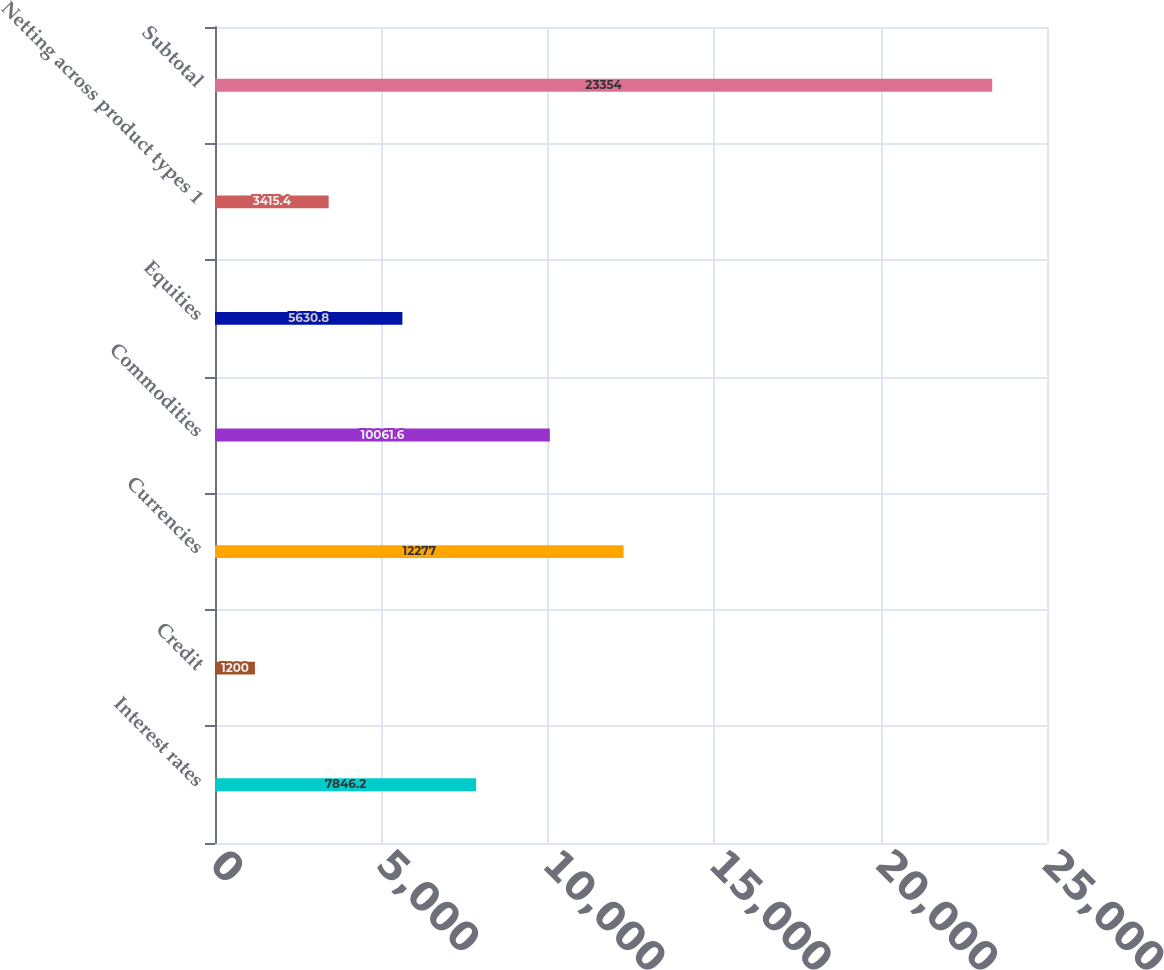Convert chart to OTSL. <chart><loc_0><loc_0><loc_500><loc_500><bar_chart><fcel>Interest rates<fcel>Credit<fcel>Currencies<fcel>Commodities<fcel>Equities<fcel>Netting across product types 1<fcel>Subtotal<nl><fcel>7846.2<fcel>1200<fcel>12277<fcel>10061.6<fcel>5630.8<fcel>3415.4<fcel>23354<nl></chart> 